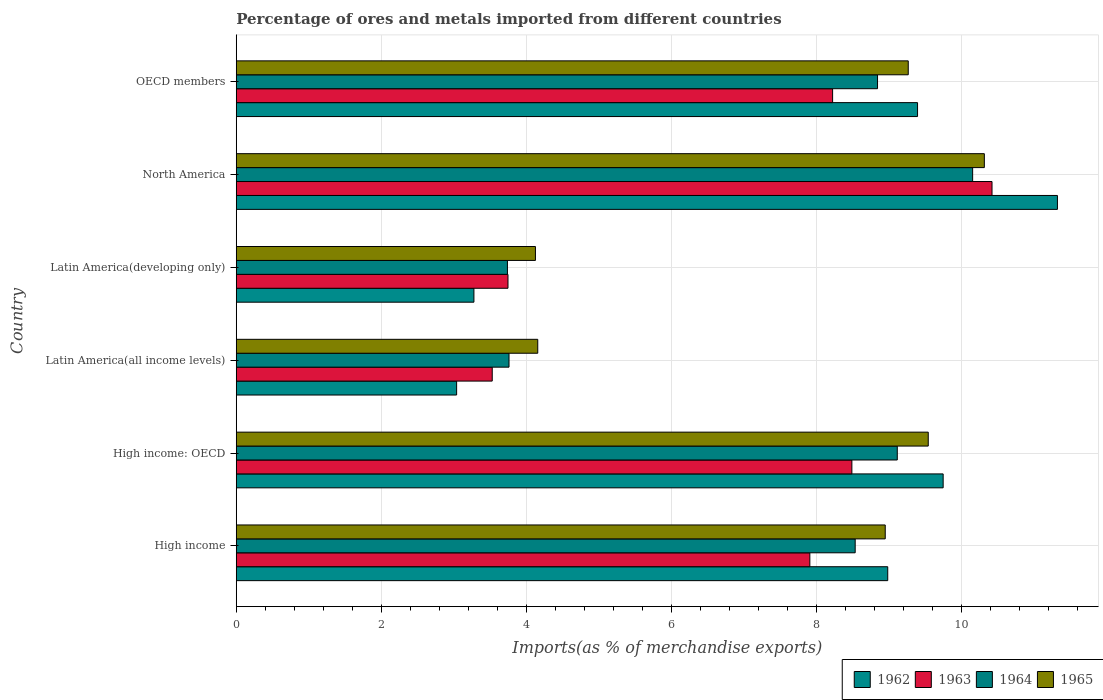Are the number of bars per tick equal to the number of legend labels?
Keep it short and to the point. Yes. What is the label of the 5th group of bars from the top?
Offer a terse response. High income: OECD. What is the percentage of imports to different countries in 1963 in Latin America(all income levels)?
Your answer should be very brief. 3.53. Across all countries, what is the maximum percentage of imports to different countries in 1963?
Provide a short and direct response. 10.42. Across all countries, what is the minimum percentage of imports to different countries in 1962?
Keep it short and to the point. 3.04. In which country was the percentage of imports to different countries in 1963 minimum?
Your answer should be very brief. Latin America(all income levels). What is the total percentage of imports to different countries in 1963 in the graph?
Your response must be concise. 42.32. What is the difference between the percentage of imports to different countries in 1963 in Latin America(developing only) and that in North America?
Provide a short and direct response. -6.67. What is the difference between the percentage of imports to different countries in 1962 in High income and the percentage of imports to different countries in 1963 in North America?
Offer a very short reply. -1.44. What is the average percentage of imports to different countries in 1964 per country?
Offer a very short reply. 7.36. What is the difference between the percentage of imports to different countries in 1962 and percentage of imports to different countries in 1964 in Latin America(all income levels)?
Your answer should be very brief. -0.72. In how many countries, is the percentage of imports to different countries in 1964 greater than 4.4 %?
Provide a succinct answer. 4. What is the ratio of the percentage of imports to different countries in 1963 in North America to that in OECD members?
Provide a succinct answer. 1.27. Is the percentage of imports to different countries in 1963 in High income less than that in Latin America(all income levels)?
Offer a terse response. No. What is the difference between the highest and the second highest percentage of imports to different countries in 1965?
Ensure brevity in your answer.  0.77. What is the difference between the highest and the lowest percentage of imports to different countries in 1963?
Offer a very short reply. 6.89. In how many countries, is the percentage of imports to different countries in 1962 greater than the average percentage of imports to different countries in 1962 taken over all countries?
Provide a succinct answer. 4. What does the 2nd bar from the top in North America represents?
Provide a short and direct response. 1964. What does the 3rd bar from the bottom in Latin America(all income levels) represents?
Make the answer very short. 1964. Is it the case that in every country, the sum of the percentage of imports to different countries in 1963 and percentage of imports to different countries in 1964 is greater than the percentage of imports to different countries in 1965?
Offer a terse response. Yes. How many bars are there?
Make the answer very short. 24. How many countries are there in the graph?
Make the answer very short. 6. What is the difference between two consecutive major ticks on the X-axis?
Ensure brevity in your answer.  2. Does the graph contain grids?
Give a very brief answer. Yes. Where does the legend appear in the graph?
Offer a terse response. Bottom right. What is the title of the graph?
Keep it short and to the point. Percentage of ores and metals imported from different countries. Does "1962" appear as one of the legend labels in the graph?
Your answer should be compact. Yes. What is the label or title of the X-axis?
Your answer should be very brief. Imports(as % of merchandise exports). What is the label or title of the Y-axis?
Give a very brief answer. Country. What is the Imports(as % of merchandise exports) in 1962 in High income?
Provide a short and direct response. 8.98. What is the Imports(as % of merchandise exports) of 1963 in High income?
Keep it short and to the point. 7.91. What is the Imports(as % of merchandise exports) of 1964 in High income?
Make the answer very short. 8.53. What is the Imports(as % of merchandise exports) in 1965 in High income?
Your answer should be very brief. 8.95. What is the Imports(as % of merchandise exports) of 1962 in High income: OECD?
Offer a terse response. 9.75. What is the Imports(as % of merchandise exports) in 1963 in High income: OECD?
Your answer should be compact. 8.49. What is the Imports(as % of merchandise exports) of 1964 in High income: OECD?
Give a very brief answer. 9.11. What is the Imports(as % of merchandise exports) in 1965 in High income: OECD?
Keep it short and to the point. 9.54. What is the Imports(as % of merchandise exports) of 1962 in Latin America(all income levels)?
Offer a terse response. 3.04. What is the Imports(as % of merchandise exports) of 1963 in Latin America(all income levels)?
Give a very brief answer. 3.53. What is the Imports(as % of merchandise exports) of 1964 in Latin America(all income levels)?
Provide a succinct answer. 3.76. What is the Imports(as % of merchandise exports) in 1965 in Latin America(all income levels)?
Give a very brief answer. 4.16. What is the Imports(as % of merchandise exports) of 1962 in Latin America(developing only)?
Offer a terse response. 3.28. What is the Imports(as % of merchandise exports) in 1963 in Latin America(developing only)?
Provide a succinct answer. 3.75. What is the Imports(as % of merchandise exports) of 1964 in Latin America(developing only)?
Provide a succinct answer. 3.74. What is the Imports(as % of merchandise exports) in 1965 in Latin America(developing only)?
Provide a succinct answer. 4.13. What is the Imports(as % of merchandise exports) of 1962 in North America?
Your answer should be very brief. 11.32. What is the Imports(as % of merchandise exports) in 1963 in North America?
Your answer should be very brief. 10.42. What is the Imports(as % of merchandise exports) in 1964 in North America?
Offer a terse response. 10.15. What is the Imports(as % of merchandise exports) of 1965 in North America?
Provide a succinct answer. 10.31. What is the Imports(as % of merchandise exports) in 1962 in OECD members?
Provide a short and direct response. 9.39. What is the Imports(as % of merchandise exports) of 1963 in OECD members?
Your response must be concise. 8.22. What is the Imports(as % of merchandise exports) in 1964 in OECD members?
Provide a succinct answer. 8.84. What is the Imports(as % of merchandise exports) in 1965 in OECD members?
Give a very brief answer. 9.27. Across all countries, what is the maximum Imports(as % of merchandise exports) in 1962?
Your answer should be very brief. 11.32. Across all countries, what is the maximum Imports(as % of merchandise exports) in 1963?
Offer a terse response. 10.42. Across all countries, what is the maximum Imports(as % of merchandise exports) in 1964?
Give a very brief answer. 10.15. Across all countries, what is the maximum Imports(as % of merchandise exports) in 1965?
Keep it short and to the point. 10.31. Across all countries, what is the minimum Imports(as % of merchandise exports) in 1962?
Make the answer very short. 3.04. Across all countries, what is the minimum Imports(as % of merchandise exports) in 1963?
Provide a short and direct response. 3.53. Across all countries, what is the minimum Imports(as % of merchandise exports) in 1964?
Provide a succinct answer. 3.74. Across all countries, what is the minimum Imports(as % of merchandise exports) in 1965?
Keep it short and to the point. 4.13. What is the total Imports(as % of merchandise exports) in 1962 in the graph?
Keep it short and to the point. 45.76. What is the total Imports(as % of merchandise exports) in 1963 in the graph?
Offer a very short reply. 42.32. What is the total Imports(as % of merchandise exports) in 1964 in the graph?
Your answer should be very brief. 44.14. What is the total Imports(as % of merchandise exports) of 1965 in the graph?
Offer a terse response. 46.35. What is the difference between the Imports(as % of merchandise exports) of 1962 in High income and that in High income: OECD?
Offer a terse response. -0.76. What is the difference between the Imports(as % of merchandise exports) of 1963 in High income and that in High income: OECD?
Your answer should be very brief. -0.58. What is the difference between the Imports(as % of merchandise exports) of 1964 in High income and that in High income: OECD?
Give a very brief answer. -0.58. What is the difference between the Imports(as % of merchandise exports) in 1965 in High income and that in High income: OECD?
Your answer should be compact. -0.59. What is the difference between the Imports(as % of merchandise exports) of 1962 in High income and that in Latin America(all income levels)?
Ensure brevity in your answer.  5.94. What is the difference between the Imports(as % of merchandise exports) of 1963 in High income and that in Latin America(all income levels)?
Provide a short and direct response. 4.38. What is the difference between the Imports(as % of merchandise exports) of 1964 in High income and that in Latin America(all income levels)?
Your answer should be compact. 4.77. What is the difference between the Imports(as % of merchandise exports) in 1965 in High income and that in Latin America(all income levels)?
Keep it short and to the point. 4.79. What is the difference between the Imports(as % of merchandise exports) in 1962 in High income and that in Latin America(developing only)?
Keep it short and to the point. 5.71. What is the difference between the Imports(as % of merchandise exports) of 1963 in High income and that in Latin America(developing only)?
Offer a very short reply. 4.16. What is the difference between the Imports(as % of merchandise exports) of 1964 in High income and that in Latin America(developing only)?
Your answer should be compact. 4.79. What is the difference between the Imports(as % of merchandise exports) in 1965 in High income and that in Latin America(developing only)?
Keep it short and to the point. 4.82. What is the difference between the Imports(as % of merchandise exports) in 1962 in High income and that in North America?
Provide a short and direct response. -2.34. What is the difference between the Imports(as % of merchandise exports) of 1963 in High income and that in North America?
Offer a very short reply. -2.51. What is the difference between the Imports(as % of merchandise exports) of 1964 in High income and that in North America?
Offer a very short reply. -1.62. What is the difference between the Imports(as % of merchandise exports) of 1965 in High income and that in North America?
Your answer should be very brief. -1.37. What is the difference between the Imports(as % of merchandise exports) in 1962 in High income and that in OECD members?
Keep it short and to the point. -0.41. What is the difference between the Imports(as % of merchandise exports) in 1963 in High income and that in OECD members?
Your response must be concise. -0.31. What is the difference between the Imports(as % of merchandise exports) of 1964 in High income and that in OECD members?
Your answer should be compact. -0.31. What is the difference between the Imports(as % of merchandise exports) of 1965 in High income and that in OECD members?
Give a very brief answer. -0.32. What is the difference between the Imports(as % of merchandise exports) in 1962 in High income: OECD and that in Latin America(all income levels)?
Make the answer very short. 6.71. What is the difference between the Imports(as % of merchandise exports) in 1963 in High income: OECD and that in Latin America(all income levels)?
Make the answer very short. 4.96. What is the difference between the Imports(as % of merchandise exports) in 1964 in High income: OECD and that in Latin America(all income levels)?
Your answer should be compact. 5.35. What is the difference between the Imports(as % of merchandise exports) of 1965 in High income: OECD and that in Latin America(all income levels)?
Provide a succinct answer. 5.38. What is the difference between the Imports(as % of merchandise exports) in 1962 in High income: OECD and that in Latin America(developing only)?
Your response must be concise. 6.47. What is the difference between the Imports(as % of merchandise exports) in 1963 in High income: OECD and that in Latin America(developing only)?
Ensure brevity in your answer.  4.74. What is the difference between the Imports(as % of merchandise exports) of 1964 in High income: OECD and that in Latin America(developing only)?
Ensure brevity in your answer.  5.38. What is the difference between the Imports(as % of merchandise exports) of 1965 in High income: OECD and that in Latin America(developing only)?
Your answer should be very brief. 5.42. What is the difference between the Imports(as % of merchandise exports) of 1962 in High income: OECD and that in North America?
Keep it short and to the point. -1.58. What is the difference between the Imports(as % of merchandise exports) of 1963 in High income: OECD and that in North America?
Keep it short and to the point. -1.93. What is the difference between the Imports(as % of merchandise exports) in 1964 in High income: OECD and that in North America?
Your response must be concise. -1.04. What is the difference between the Imports(as % of merchandise exports) in 1965 in High income: OECD and that in North America?
Provide a succinct answer. -0.77. What is the difference between the Imports(as % of merchandise exports) in 1962 in High income: OECD and that in OECD members?
Your answer should be compact. 0.35. What is the difference between the Imports(as % of merchandise exports) in 1963 in High income: OECD and that in OECD members?
Give a very brief answer. 0.27. What is the difference between the Imports(as % of merchandise exports) of 1964 in High income: OECD and that in OECD members?
Give a very brief answer. 0.27. What is the difference between the Imports(as % of merchandise exports) of 1965 in High income: OECD and that in OECD members?
Your answer should be compact. 0.28. What is the difference between the Imports(as % of merchandise exports) of 1962 in Latin America(all income levels) and that in Latin America(developing only)?
Make the answer very short. -0.24. What is the difference between the Imports(as % of merchandise exports) in 1963 in Latin America(all income levels) and that in Latin America(developing only)?
Offer a very short reply. -0.22. What is the difference between the Imports(as % of merchandise exports) of 1964 in Latin America(all income levels) and that in Latin America(developing only)?
Provide a short and direct response. 0.02. What is the difference between the Imports(as % of merchandise exports) in 1965 in Latin America(all income levels) and that in Latin America(developing only)?
Keep it short and to the point. 0.03. What is the difference between the Imports(as % of merchandise exports) in 1962 in Latin America(all income levels) and that in North America?
Offer a very short reply. -8.28. What is the difference between the Imports(as % of merchandise exports) of 1963 in Latin America(all income levels) and that in North America?
Offer a terse response. -6.89. What is the difference between the Imports(as % of merchandise exports) in 1964 in Latin America(all income levels) and that in North America?
Your answer should be compact. -6.39. What is the difference between the Imports(as % of merchandise exports) in 1965 in Latin America(all income levels) and that in North America?
Provide a succinct answer. -6.16. What is the difference between the Imports(as % of merchandise exports) of 1962 in Latin America(all income levels) and that in OECD members?
Offer a very short reply. -6.36. What is the difference between the Imports(as % of merchandise exports) in 1963 in Latin America(all income levels) and that in OECD members?
Offer a very short reply. -4.69. What is the difference between the Imports(as % of merchandise exports) in 1964 in Latin America(all income levels) and that in OECD members?
Provide a short and direct response. -5.08. What is the difference between the Imports(as % of merchandise exports) in 1965 in Latin America(all income levels) and that in OECD members?
Provide a succinct answer. -5.11. What is the difference between the Imports(as % of merchandise exports) of 1962 in Latin America(developing only) and that in North America?
Your response must be concise. -8.05. What is the difference between the Imports(as % of merchandise exports) in 1963 in Latin America(developing only) and that in North America?
Your answer should be very brief. -6.67. What is the difference between the Imports(as % of merchandise exports) in 1964 in Latin America(developing only) and that in North America?
Your answer should be compact. -6.41. What is the difference between the Imports(as % of merchandise exports) of 1965 in Latin America(developing only) and that in North America?
Give a very brief answer. -6.19. What is the difference between the Imports(as % of merchandise exports) of 1962 in Latin America(developing only) and that in OECD members?
Provide a succinct answer. -6.12. What is the difference between the Imports(as % of merchandise exports) in 1963 in Latin America(developing only) and that in OECD members?
Give a very brief answer. -4.48. What is the difference between the Imports(as % of merchandise exports) in 1964 in Latin America(developing only) and that in OECD members?
Ensure brevity in your answer.  -5.1. What is the difference between the Imports(as % of merchandise exports) in 1965 in Latin America(developing only) and that in OECD members?
Offer a terse response. -5.14. What is the difference between the Imports(as % of merchandise exports) in 1962 in North America and that in OECD members?
Ensure brevity in your answer.  1.93. What is the difference between the Imports(as % of merchandise exports) of 1963 in North America and that in OECD members?
Ensure brevity in your answer.  2.2. What is the difference between the Imports(as % of merchandise exports) of 1964 in North America and that in OECD members?
Your answer should be very brief. 1.31. What is the difference between the Imports(as % of merchandise exports) of 1965 in North America and that in OECD members?
Your response must be concise. 1.05. What is the difference between the Imports(as % of merchandise exports) in 1962 in High income and the Imports(as % of merchandise exports) in 1963 in High income: OECD?
Your answer should be compact. 0.49. What is the difference between the Imports(as % of merchandise exports) of 1962 in High income and the Imports(as % of merchandise exports) of 1964 in High income: OECD?
Offer a very short reply. -0.13. What is the difference between the Imports(as % of merchandise exports) in 1962 in High income and the Imports(as % of merchandise exports) in 1965 in High income: OECD?
Offer a terse response. -0.56. What is the difference between the Imports(as % of merchandise exports) in 1963 in High income and the Imports(as % of merchandise exports) in 1964 in High income: OECD?
Provide a short and direct response. -1.21. What is the difference between the Imports(as % of merchandise exports) of 1963 in High income and the Imports(as % of merchandise exports) of 1965 in High income: OECD?
Provide a succinct answer. -1.63. What is the difference between the Imports(as % of merchandise exports) in 1964 in High income and the Imports(as % of merchandise exports) in 1965 in High income: OECD?
Offer a very short reply. -1.01. What is the difference between the Imports(as % of merchandise exports) of 1962 in High income and the Imports(as % of merchandise exports) of 1963 in Latin America(all income levels)?
Your answer should be very brief. 5.45. What is the difference between the Imports(as % of merchandise exports) of 1962 in High income and the Imports(as % of merchandise exports) of 1964 in Latin America(all income levels)?
Provide a short and direct response. 5.22. What is the difference between the Imports(as % of merchandise exports) of 1962 in High income and the Imports(as % of merchandise exports) of 1965 in Latin America(all income levels)?
Your answer should be very brief. 4.83. What is the difference between the Imports(as % of merchandise exports) in 1963 in High income and the Imports(as % of merchandise exports) in 1964 in Latin America(all income levels)?
Your answer should be very brief. 4.15. What is the difference between the Imports(as % of merchandise exports) in 1963 in High income and the Imports(as % of merchandise exports) in 1965 in Latin America(all income levels)?
Provide a short and direct response. 3.75. What is the difference between the Imports(as % of merchandise exports) of 1964 in High income and the Imports(as % of merchandise exports) of 1965 in Latin America(all income levels)?
Give a very brief answer. 4.38. What is the difference between the Imports(as % of merchandise exports) of 1962 in High income and the Imports(as % of merchandise exports) of 1963 in Latin America(developing only)?
Your response must be concise. 5.24. What is the difference between the Imports(as % of merchandise exports) of 1962 in High income and the Imports(as % of merchandise exports) of 1964 in Latin America(developing only)?
Offer a terse response. 5.24. What is the difference between the Imports(as % of merchandise exports) in 1962 in High income and the Imports(as % of merchandise exports) in 1965 in Latin America(developing only)?
Offer a very short reply. 4.86. What is the difference between the Imports(as % of merchandise exports) in 1963 in High income and the Imports(as % of merchandise exports) in 1964 in Latin America(developing only)?
Your answer should be very brief. 4.17. What is the difference between the Imports(as % of merchandise exports) in 1963 in High income and the Imports(as % of merchandise exports) in 1965 in Latin America(developing only)?
Your answer should be very brief. 3.78. What is the difference between the Imports(as % of merchandise exports) of 1964 in High income and the Imports(as % of merchandise exports) of 1965 in Latin America(developing only)?
Make the answer very short. 4.41. What is the difference between the Imports(as % of merchandise exports) in 1962 in High income and the Imports(as % of merchandise exports) in 1963 in North America?
Provide a short and direct response. -1.44. What is the difference between the Imports(as % of merchandise exports) in 1962 in High income and the Imports(as % of merchandise exports) in 1964 in North America?
Provide a succinct answer. -1.17. What is the difference between the Imports(as % of merchandise exports) in 1962 in High income and the Imports(as % of merchandise exports) in 1965 in North America?
Provide a short and direct response. -1.33. What is the difference between the Imports(as % of merchandise exports) in 1963 in High income and the Imports(as % of merchandise exports) in 1964 in North America?
Your answer should be very brief. -2.24. What is the difference between the Imports(as % of merchandise exports) of 1963 in High income and the Imports(as % of merchandise exports) of 1965 in North America?
Your answer should be very brief. -2.41. What is the difference between the Imports(as % of merchandise exports) of 1964 in High income and the Imports(as % of merchandise exports) of 1965 in North America?
Provide a succinct answer. -1.78. What is the difference between the Imports(as % of merchandise exports) of 1962 in High income and the Imports(as % of merchandise exports) of 1963 in OECD members?
Offer a very short reply. 0.76. What is the difference between the Imports(as % of merchandise exports) in 1962 in High income and the Imports(as % of merchandise exports) in 1964 in OECD members?
Provide a short and direct response. 0.14. What is the difference between the Imports(as % of merchandise exports) in 1962 in High income and the Imports(as % of merchandise exports) in 1965 in OECD members?
Give a very brief answer. -0.28. What is the difference between the Imports(as % of merchandise exports) of 1963 in High income and the Imports(as % of merchandise exports) of 1964 in OECD members?
Your response must be concise. -0.93. What is the difference between the Imports(as % of merchandise exports) in 1963 in High income and the Imports(as % of merchandise exports) in 1965 in OECD members?
Provide a short and direct response. -1.36. What is the difference between the Imports(as % of merchandise exports) of 1964 in High income and the Imports(as % of merchandise exports) of 1965 in OECD members?
Make the answer very short. -0.73. What is the difference between the Imports(as % of merchandise exports) in 1962 in High income: OECD and the Imports(as % of merchandise exports) in 1963 in Latin America(all income levels)?
Ensure brevity in your answer.  6.22. What is the difference between the Imports(as % of merchandise exports) in 1962 in High income: OECD and the Imports(as % of merchandise exports) in 1964 in Latin America(all income levels)?
Offer a very short reply. 5.99. What is the difference between the Imports(as % of merchandise exports) of 1962 in High income: OECD and the Imports(as % of merchandise exports) of 1965 in Latin America(all income levels)?
Provide a succinct answer. 5.59. What is the difference between the Imports(as % of merchandise exports) in 1963 in High income: OECD and the Imports(as % of merchandise exports) in 1964 in Latin America(all income levels)?
Offer a terse response. 4.73. What is the difference between the Imports(as % of merchandise exports) in 1963 in High income: OECD and the Imports(as % of merchandise exports) in 1965 in Latin America(all income levels)?
Make the answer very short. 4.33. What is the difference between the Imports(as % of merchandise exports) of 1964 in High income: OECD and the Imports(as % of merchandise exports) of 1965 in Latin America(all income levels)?
Ensure brevity in your answer.  4.96. What is the difference between the Imports(as % of merchandise exports) in 1962 in High income: OECD and the Imports(as % of merchandise exports) in 1963 in Latin America(developing only)?
Your answer should be very brief. 6. What is the difference between the Imports(as % of merchandise exports) of 1962 in High income: OECD and the Imports(as % of merchandise exports) of 1964 in Latin America(developing only)?
Ensure brevity in your answer.  6.01. What is the difference between the Imports(as % of merchandise exports) in 1962 in High income: OECD and the Imports(as % of merchandise exports) in 1965 in Latin America(developing only)?
Offer a terse response. 5.62. What is the difference between the Imports(as % of merchandise exports) of 1963 in High income: OECD and the Imports(as % of merchandise exports) of 1964 in Latin America(developing only)?
Your answer should be compact. 4.75. What is the difference between the Imports(as % of merchandise exports) in 1963 in High income: OECD and the Imports(as % of merchandise exports) in 1965 in Latin America(developing only)?
Give a very brief answer. 4.36. What is the difference between the Imports(as % of merchandise exports) in 1964 in High income: OECD and the Imports(as % of merchandise exports) in 1965 in Latin America(developing only)?
Offer a terse response. 4.99. What is the difference between the Imports(as % of merchandise exports) of 1962 in High income: OECD and the Imports(as % of merchandise exports) of 1963 in North America?
Offer a very short reply. -0.67. What is the difference between the Imports(as % of merchandise exports) in 1962 in High income: OECD and the Imports(as % of merchandise exports) in 1964 in North America?
Keep it short and to the point. -0.41. What is the difference between the Imports(as % of merchandise exports) of 1962 in High income: OECD and the Imports(as % of merchandise exports) of 1965 in North America?
Your answer should be compact. -0.57. What is the difference between the Imports(as % of merchandise exports) of 1963 in High income: OECD and the Imports(as % of merchandise exports) of 1964 in North America?
Your answer should be compact. -1.67. What is the difference between the Imports(as % of merchandise exports) in 1963 in High income: OECD and the Imports(as % of merchandise exports) in 1965 in North America?
Make the answer very short. -1.83. What is the difference between the Imports(as % of merchandise exports) in 1964 in High income: OECD and the Imports(as % of merchandise exports) in 1965 in North America?
Give a very brief answer. -1.2. What is the difference between the Imports(as % of merchandise exports) of 1962 in High income: OECD and the Imports(as % of merchandise exports) of 1963 in OECD members?
Provide a short and direct response. 1.52. What is the difference between the Imports(as % of merchandise exports) in 1962 in High income: OECD and the Imports(as % of merchandise exports) in 1964 in OECD members?
Provide a short and direct response. 0.9. What is the difference between the Imports(as % of merchandise exports) in 1962 in High income: OECD and the Imports(as % of merchandise exports) in 1965 in OECD members?
Your response must be concise. 0.48. What is the difference between the Imports(as % of merchandise exports) in 1963 in High income: OECD and the Imports(as % of merchandise exports) in 1964 in OECD members?
Make the answer very short. -0.35. What is the difference between the Imports(as % of merchandise exports) in 1963 in High income: OECD and the Imports(as % of merchandise exports) in 1965 in OECD members?
Your answer should be very brief. -0.78. What is the difference between the Imports(as % of merchandise exports) in 1964 in High income: OECD and the Imports(as % of merchandise exports) in 1965 in OECD members?
Your answer should be very brief. -0.15. What is the difference between the Imports(as % of merchandise exports) of 1962 in Latin America(all income levels) and the Imports(as % of merchandise exports) of 1963 in Latin America(developing only)?
Make the answer very short. -0.71. What is the difference between the Imports(as % of merchandise exports) of 1962 in Latin America(all income levels) and the Imports(as % of merchandise exports) of 1964 in Latin America(developing only)?
Provide a short and direct response. -0.7. What is the difference between the Imports(as % of merchandise exports) in 1962 in Latin America(all income levels) and the Imports(as % of merchandise exports) in 1965 in Latin America(developing only)?
Your response must be concise. -1.09. What is the difference between the Imports(as % of merchandise exports) in 1963 in Latin America(all income levels) and the Imports(as % of merchandise exports) in 1964 in Latin America(developing only)?
Your answer should be compact. -0.21. What is the difference between the Imports(as % of merchandise exports) of 1963 in Latin America(all income levels) and the Imports(as % of merchandise exports) of 1965 in Latin America(developing only)?
Your answer should be very brief. -0.6. What is the difference between the Imports(as % of merchandise exports) of 1964 in Latin America(all income levels) and the Imports(as % of merchandise exports) of 1965 in Latin America(developing only)?
Give a very brief answer. -0.36. What is the difference between the Imports(as % of merchandise exports) in 1962 in Latin America(all income levels) and the Imports(as % of merchandise exports) in 1963 in North America?
Keep it short and to the point. -7.38. What is the difference between the Imports(as % of merchandise exports) in 1962 in Latin America(all income levels) and the Imports(as % of merchandise exports) in 1964 in North America?
Your answer should be compact. -7.11. What is the difference between the Imports(as % of merchandise exports) of 1962 in Latin America(all income levels) and the Imports(as % of merchandise exports) of 1965 in North America?
Give a very brief answer. -7.28. What is the difference between the Imports(as % of merchandise exports) of 1963 in Latin America(all income levels) and the Imports(as % of merchandise exports) of 1964 in North America?
Your answer should be very brief. -6.62. What is the difference between the Imports(as % of merchandise exports) of 1963 in Latin America(all income levels) and the Imports(as % of merchandise exports) of 1965 in North America?
Your answer should be very brief. -6.79. What is the difference between the Imports(as % of merchandise exports) of 1964 in Latin America(all income levels) and the Imports(as % of merchandise exports) of 1965 in North America?
Your answer should be very brief. -6.55. What is the difference between the Imports(as % of merchandise exports) of 1962 in Latin America(all income levels) and the Imports(as % of merchandise exports) of 1963 in OECD members?
Offer a very short reply. -5.18. What is the difference between the Imports(as % of merchandise exports) of 1962 in Latin America(all income levels) and the Imports(as % of merchandise exports) of 1964 in OECD members?
Give a very brief answer. -5.8. What is the difference between the Imports(as % of merchandise exports) in 1962 in Latin America(all income levels) and the Imports(as % of merchandise exports) in 1965 in OECD members?
Give a very brief answer. -6.23. What is the difference between the Imports(as % of merchandise exports) in 1963 in Latin America(all income levels) and the Imports(as % of merchandise exports) in 1964 in OECD members?
Offer a terse response. -5.31. What is the difference between the Imports(as % of merchandise exports) of 1963 in Latin America(all income levels) and the Imports(as % of merchandise exports) of 1965 in OECD members?
Make the answer very short. -5.74. What is the difference between the Imports(as % of merchandise exports) in 1964 in Latin America(all income levels) and the Imports(as % of merchandise exports) in 1965 in OECD members?
Keep it short and to the point. -5.5. What is the difference between the Imports(as % of merchandise exports) of 1962 in Latin America(developing only) and the Imports(as % of merchandise exports) of 1963 in North America?
Ensure brevity in your answer.  -7.14. What is the difference between the Imports(as % of merchandise exports) in 1962 in Latin America(developing only) and the Imports(as % of merchandise exports) in 1964 in North America?
Keep it short and to the point. -6.88. What is the difference between the Imports(as % of merchandise exports) in 1962 in Latin America(developing only) and the Imports(as % of merchandise exports) in 1965 in North America?
Offer a terse response. -7.04. What is the difference between the Imports(as % of merchandise exports) in 1963 in Latin America(developing only) and the Imports(as % of merchandise exports) in 1964 in North America?
Ensure brevity in your answer.  -6.41. What is the difference between the Imports(as % of merchandise exports) in 1963 in Latin America(developing only) and the Imports(as % of merchandise exports) in 1965 in North America?
Your response must be concise. -6.57. What is the difference between the Imports(as % of merchandise exports) in 1964 in Latin America(developing only) and the Imports(as % of merchandise exports) in 1965 in North America?
Your response must be concise. -6.58. What is the difference between the Imports(as % of merchandise exports) of 1962 in Latin America(developing only) and the Imports(as % of merchandise exports) of 1963 in OECD members?
Offer a terse response. -4.95. What is the difference between the Imports(as % of merchandise exports) of 1962 in Latin America(developing only) and the Imports(as % of merchandise exports) of 1964 in OECD members?
Make the answer very short. -5.57. What is the difference between the Imports(as % of merchandise exports) in 1962 in Latin America(developing only) and the Imports(as % of merchandise exports) in 1965 in OECD members?
Keep it short and to the point. -5.99. What is the difference between the Imports(as % of merchandise exports) of 1963 in Latin America(developing only) and the Imports(as % of merchandise exports) of 1964 in OECD members?
Provide a short and direct response. -5.1. What is the difference between the Imports(as % of merchandise exports) in 1963 in Latin America(developing only) and the Imports(as % of merchandise exports) in 1965 in OECD members?
Your response must be concise. -5.52. What is the difference between the Imports(as % of merchandise exports) of 1964 in Latin America(developing only) and the Imports(as % of merchandise exports) of 1965 in OECD members?
Your answer should be compact. -5.53. What is the difference between the Imports(as % of merchandise exports) of 1962 in North America and the Imports(as % of merchandise exports) of 1964 in OECD members?
Give a very brief answer. 2.48. What is the difference between the Imports(as % of merchandise exports) in 1962 in North America and the Imports(as % of merchandise exports) in 1965 in OECD members?
Offer a very short reply. 2.06. What is the difference between the Imports(as % of merchandise exports) of 1963 in North America and the Imports(as % of merchandise exports) of 1964 in OECD members?
Offer a terse response. 1.58. What is the difference between the Imports(as % of merchandise exports) in 1963 in North America and the Imports(as % of merchandise exports) in 1965 in OECD members?
Offer a terse response. 1.16. What is the difference between the Imports(as % of merchandise exports) in 1964 in North America and the Imports(as % of merchandise exports) in 1965 in OECD members?
Give a very brief answer. 0.89. What is the average Imports(as % of merchandise exports) in 1962 per country?
Your response must be concise. 7.63. What is the average Imports(as % of merchandise exports) in 1963 per country?
Your answer should be very brief. 7.05. What is the average Imports(as % of merchandise exports) in 1964 per country?
Keep it short and to the point. 7.36. What is the average Imports(as % of merchandise exports) of 1965 per country?
Offer a very short reply. 7.73. What is the difference between the Imports(as % of merchandise exports) of 1962 and Imports(as % of merchandise exports) of 1963 in High income?
Your answer should be very brief. 1.07. What is the difference between the Imports(as % of merchandise exports) of 1962 and Imports(as % of merchandise exports) of 1964 in High income?
Your answer should be very brief. 0.45. What is the difference between the Imports(as % of merchandise exports) in 1962 and Imports(as % of merchandise exports) in 1965 in High income?
Provide a succinct answer. 0.03. What is the difference between the Imports(as % of merchandise exports) in 1963 and Imports(as % of merchandise exports) in 1964 in High income?
Give a very brief answer. -0.63. What is the difference between the Imports(as % of merchandise exports) in 1963 and Imports(as % of merchandise exports) in 1965 in High income?
Give a very brief answer. -1.04. What is the difference between the Imports(as % of merchandise exports) of 1964 and Imports(as % of merchandise exports) of 1965 in High income?
Your response must be concise. -0.41. What is the difference between the Imports(as % of merchandise exports) in 1962 and Imports(as % of merchandise exports) in 1963 in High income: OECD?
Provide a short and direct response. 1.26. What is the difference between the Imports(as % of merchandise exports) in 1962 and Imports(as % of merchandise exports) in 1964 in High income: OECD?
Offer a terse response. 0.63. What is the difference between the Imports(as % of merchandise exports) of 1962 and Imports(as % of merchandise exports) of 1965 in High income: OECD?
Your answer should be compact. 0.21. What is the difference between the Imports(as % of merchandise exports) of 1963 and Imports(as % of merchandise exports) of 1964 in High income: OECD?
Your response must be concise. -0.63. What is the difference between the Imports(as % of merchandise exports) of 1963 and Imports(as % of merchandise exports) of 1965 in High income: OECD?
Your answer should be compact. -1.05. What is the difference between the Imports(as % of merchandise exports) of 1964 and Imports(as % of merchandise exports) of 1965 in High income: OECD?
Your answer should be compact. -0.43. What is the difference between the Imports(as % of merchandise exports) of 1962 and Imports(as % of merchandise exports) of 1963 in Latin America(all income levels)?
Provide a short and direct response. -0.49. What is the difference between the Imports(as % of merchandise exports) in 1962 and Imports(as % of merchandise exports) in 1964 in Latin America(all income levels)?
Give a very brief answer. -0.72. What is the difference between the Imports(as % of merchandise exports) of 1962 and Imports(as % of merchandise exports) of 1965 in Latin America(all income levels)?
Make the answer very short. -1.12. What is the difference between the Imports(as % of merchandise exports) in 1963 and Imports(as % of merchandise exports) in 1964 in Latin America(all income levels)?
Provide a short and direct response. -0.23. What is the difference between the Imports(as % of merchandise exports) of 1963 and Imports(as % of merchandise exports) of 1965 in Latin America(all income levels)?
Provide a short and direct response. -0.63. What is the difference between the Imports(as % of merchandise exports) in 1964 and Imports(as % of merchandise exports) in 1965 in Latin America(all income levels)?
Ensure brevity in your answer.  -0.4. What is the difference between the Imports(as % of merchandise exports) in 1962 and Imports(as % of merchandise exports) in 1963 in Latin America(developing only)?
Offer a very short reply. -0.47. What is the difference between the Imports(as % of merchandise exports) in 1962 and Imports(as % of merchandise exports) in 1964 in Latin America(developing only)?
Your response must be concise. -0.46. What is the difference between the Imports(as % of merchandise exports) in 1962 and Imports(as % of merchandise exports) in 1965 in Latin America(developing only)?
Offer a very short reply. -0.85. What is the difference between the Imports(as % of merchandise exports) in 1963 and Imports(as % of merchandise exports) in 1964 in Latin America(developing only)?
Your response must be concise. 0.01. What is the difference between the Imports(as % of merchandise exports) in 1963 and Imports(as % of merchandise exports) in 1965 in Latin America(developing only)?
Offer a terse response. -0.38. What is the difference between the Imports(as % of merchandise exports) in 1964 and Imports(as % of merchandise exports) in 1965 in Latin America(developing only)?
Keep it short and to the point. -0.39. What is the difference between the Imports(as % of merchandise exports) of 1962 and Imports(as % of merchandise exports) of 1963 in North America?
Offer a very short reply. 0.9. What is the difference between the Imports(as % of merchandise exports) of 1962 and Imports(as % of merchandise exports) of 1964 in North America?
Give a very brief answer. 1.17. What is the difference between the Imports(as % of merchandise exports) in 1962 and Imports(as % of merchandise exports) in 1965 in North America?
Your answer should be very brief. 1.01. What is the difference between the Imports(as % of merchandise exports) in 1963 and Imports(as % of merchandise exports) in 1964 in North America?
Offer a terse response. 0.27. What is the difference between the Imports(as % of merchandise exports) in 1963 and Imports(as % of merchandise exports) in 1965 in North America?
Ensure brevity in your answer.  0.11. What is the difference between the Imports(as % of merchandise exports) in 1964 and Imports(as % of merchandise exports) in 1965 in North America?
Ensure brevity in your answer.  -0.16. What is the difference between the Imports(as % of merchandise exports) of 1962 and Imports(as % of merchandise exports) of 1963 in OECD members?
Your answer should be compact. 1.17. What is the difference between the Imports(as % of merchandise exports) of 1962 and Imports(as % of merchandise exports) of 1964 in OECD members?
Your answer should be very brief. 0.55. What is the difference between the Imports(as % of merchandise exports) of 1962 and Imports(as % of merchandise exports) of 1965 in OECD members?
Ensure brevity in your answer.  0.13. What is the difference between the Imports(as % of merchandise exports) in 1963 and Imports(as % of merchandise exports) in 1964 in OECD members?
Make the answer very short. -0.62. What is the difference between the Imports(as % of merchandise exports) in 1963 and Imports(as % of merchandise exports) in 1965 in OECD members?
Your answer should be compact. -1.04. What is the difference between the Imports(as % of merchandise exports) in 1964 and Imports(as % of merchandise exports) in 1965 in OECD members?
Your response must be concise. -0.42. What is the ratio of the Imports(as % of merchandise exports) in 1962 in High income to that in High income: OECD?
Give a very brief answer. 0.92. What is the ratio of the Imports(as % of merchandise exports) in 1963 in High income to that in High income: OECD?
Your answer should be very brief. 0.93. What is the ratio of the Imports(as % of merchandise exports) in 1964 in High income to that in High income: OECD?
Offer a terse response. 0.94. What is the ratio of the Imports(as % of merchandise exports) in 1965 in High income to that in High income: OECD?
Ensure brevity in your answer.  0.94. What is the ratio of the Imports(as % of merchandise exports) in 1962 in High income to that in Latin America(all income levels)?
Your answer should be compact. 2.96. What is the ratio of the Imports(as % of merchandise exports) of 1963 in High income to that in Latin America(all income levels)?
Provide a short and direct response. 2.24. What is the ratio of the Imports(as % of merchandise exports) in 1964 in High income to that in Latin America(all income levels)?
Your answer should be compact. 2.27. What is the ratio of the Imports(as % of merchandise exports) in 1965 in High income to that in Latin America(all income levels)?
Ensure brevity in your answer.  2.15. What is the ratio of the Imports(as % of merchandise exports) of 1962 in High income to that in Latin America(developing only)?
Your response must be concise. 2.74. What is the ratio of the Imports(as % of merchandise exports) of 1963 in High income to that in Latin America(developing only)?
Offer a very short reply. 2.11. What is the ratio of the Imports(as % of merchandise exports) of 1964 in High income to that in Latin America(developing only)?
Your response must be concise. 2.28. What is the ratio of the Imports(as % of merchandise exports) of 1965 in High income to that in Latin America(developing only)?
Your response must be concise. 2.17. What is the ratio of the Imports(as % of merchandise exports) in 1962 in High income to that in North America?
Provide a succinct answer. 0.79. What is the ratio of the Imports(as % of merchandise exports) of 1963 in High income to that in North America?
Offer a terse response. 0.76. What is the ratio of the Imports(as % of merchandise exports) of 1964 in High income to that in North America?
Offer a terse response. 0.84. What is the ratio of the Imports(as % of merchandise exports) in 1965 in High income to that in North America?
Your answer should be very brief. 0.87. What is the ratio of the Imports(as % of merchandise exports) in 1962 in High income to that in OECD members?
Keep it short and to the point. 0.96. What is the ratio of the Imports(as % of merchandise exports) in 1963 in High income to that in OECD members?
Make the answer very short. 0.96. What is the ratio of the Imports(as % of merchandise exports) in 1964 in High income to that in OECD members?
Offer a very short reply. 0.97. What is the ratio of the Imports(as % of merchandise exports) in 1965 in High income to that in OECD members?
Give a very brief answer. 0.97. What is the ratio of the Imports(as % of merchandise exports) of 1962 in High income: OECD to that in Latin America(all income levels)?
Give a very brief answer. 3.21. What is the ratio of the Imports(as % of merchandise exports) in 1963 in High income: OECD to that in Latin America(all income levels)?
Offer a terse response. 2.4. What is the ratio of the Imports(as % of merchandise exports) in 1964 in High income: OECD to that in Latin America(all income levels)?
Make the answer very short. 2.42. What is the ratio of the Imports(as % of merchandise exports) in 1965 in High income: OECD to that in Latin America(all income levels)?
Give a very brief answer. 2.3. What is the ratio of the Imports(as % of merchandise exports) in 1962 in High income: OECD to that in Latin America(developing only)?
Give a very brief answer. 2.97. What is the ratio of the Imports(as % of merchandise exports) of 1963 in High income: OECD to that in Latin America(developing only)?
Give a very brief answer. 2.27. What is the ratio of the Imports(as % of merchandise exports) in 1964 in High income: OECD to that in Latin America(developing only)?
Ensure brevity in your answer.  2.44. What is the ratio of the Imports(as % of merchandise exports) in 1965 in High income: OECD to that in Latin America(developing only)?
Offer a terse response. 2.31. What is the ratio of the Imports(as % of merchandise exports) in 1962 in High income: OECD to that in North America?
Ensure brevity in your answer.  0.86. What is the ratio of the Imports(as % of merchandise exports) in 1963 in High income: OECD to that in North America?
Keep it short and to the point. 0.81. What is the ratio of the Imports(as % of merchandise exports) in 1964 in High income: OECD to that in North America?
Keep it short and to the point. 0.9. What is the ratio of the Imports(as % of merchandise exports) of 1965 in High income: OECD to that in North America?
Offer a very short reply. 0.93. What is the ratio of the Imports(as % of merchandise exports) in 1962 in High income: OECD to that in OECD members?
Provide a succinct answer. 1.04. What is the ratio of the Imports(as % of merchandise exports) of 1963 in High income: OECD to that in OECD members?
Keep it short and to the point. 1.03. What is the ratio of the Imports(as % of merchandise exports) of 1964 in High income: OECD to that in OECD members?
Your answer should be compact. 1.03. What is the ratio of the Imports(as % of merchandise exports) of 1965 in High income: OECD to that in OECD members?
Offer a terse response. 1.03. What is the ratio of the Imports(as % of merchandise exports) of 1962 in Latin America(all income levels) to that in Latin America(developing only)?
Offer a terse response. 0.93. What is the ratio of the Imports(as % of merchandise exports) of 1963 in Latin America(all income levels) to that in Latin America(developing only)?
Provide a succinct answer. 0.94. What is the ratio of the Imports(as % of merchandise exports) of 1964 in Latin America(all income levels) to that in Latin America(developing only)?
Your response must be concise. 1.01. What is the ratio of the Imports(as % of merchandise exports) in 1965 in Latin America(all income levels) to that in Latin America(developing only)?
Offer a terse response. 1.01. What is the ratio of the Imports(as % of merchandise exports) of 1962 in Latin America(all income levels) to that in North America?
Ensure brevity in your answer.  0.27. What is the ratio of the Imports(as % of merchandise exports) in 1963 in Latin America(all income levels) to that in North America?
Your answer should be very brief. 0.34. What is the ratio of the Imports(as % of merchandise exports) in 1964 in Latin America(all income levels) to that in North America?
Keep it short and to the point. 0.37. What is the ratio of the Imports(as % of merchandise exports) in 1965 in Latin America(all income levels) to that in North America?
Provide a short and direct response. 0.4. What is the ratio of the Imports(as % of merchandise exports) in 1962 in Latin America(all income levels) to that in OECD members?
Offer a very short reply. 0.32. What is the ratio of the Imports(as % of merchandise exports) in 1963 in Latin America(all income levels) to that in OECD members?
Provide a succinct answer. 0.43. What is the ratio of the Imports(as % of merchandise exports) of 1964 in Latin America(all income levels) to that in OECD members?
Make the answer very short. 0.43. What is the ratio of the Imports(as % of merchandise exports) in 1965 in Latin America(all income levels) to that in OECD members?
Make the answer very short. 0.45. What is the ratio of the Imports(as % of merchandise exports) in 1962 in Latin America(developing only) to that in North America?
Ensure brevity in your answer.  0.29. What is the ratio of the Imports(as % of merchandise exports) of 1963 in Latin America(developing only) to that in North America?
Your response must be concise. 0.36. What is the ratio of the Imports(as % of merchandise exports) of 1964 in Latin America(developing only) to that in North America?
Provide a succinct answer. 0.37. What is the ratio of the Imports(as % of merchandise exports) in 1965 in Latin America(developing only) to that in North America?
Offer a terse response. 0.4. What is the ratio of the Imports(as % of merchandise exports) in 1962 in Latin America(developing only) to that in OECD members?
Give a very brief answer. 0.35. What is the ratio of the Imports(as % of merchandise exports) of 1963 in Latin America(developing only) to that in OECD members?
Your answer should be compact. 0.46. What is the ratio of the Imports(as % of merchandise exports) of 1964 in Latin America(developing only) to that in OECD members?
Offer a terse response. 0.42. What is the ratio of the Imports(as % of merchandise exports) of 1965 in Latin America(developing only) to that in OECD members?
Your answer should be compact. 0.45. What is the ratio of the Imports(as % of merchandise exports) in 1962 in North America to that in OECD members?
Your response must be concise. 1.21. What is the ratio of the Imports(as % of merchandise exports) in 1963 in North America to that in OECD members?
Offer a terse response. 1.27. What is the ratio of the Imports(as % of merchandise exports) in 1964 in North America to that in OECD members?
Provide a short and direct response. 1.15. What is the ratio of the Imports(as % of merchandise exports) of 1965 in North America to that in OECD members?
Keep it short and to the point. 1.11. What is the difference between the highest and the second highest Imports(as % of merchandise exports) in 1962?
Your response must be concise. 1.58. What is the difference between the highest and the second highest Imports(as % of merchandise exports) of 1963?
Keep it short and to the point. 1.93. What is the difference between the highest and the second highest Imports(as % of merchandise exports) in 1964?
Provide a succinct answer. 1.04. What is the difference between the highest and the second highest Imports(as % of merchandise exports) of 1965?
Ensure brevity in your answer.  0.77. What is the difference between the highest and the lowest Imports(as % of merchandise exports) of 1962?
Provide a short and direct response. 8.28. What is the difference between the highest and the lowest Imports(as % of merchandise exports) of 1963?
Ensure brevity in your answer.  6.89. What is the difference between the highest and the lowest Imports(as % of merchandise exports) in 1964?
Your answer should be very brief. 6.41. What is the difference between the highest and the lowest Imports(as % of merchandise exports) in 1965?
Provide a short and direct response. 6.19. 